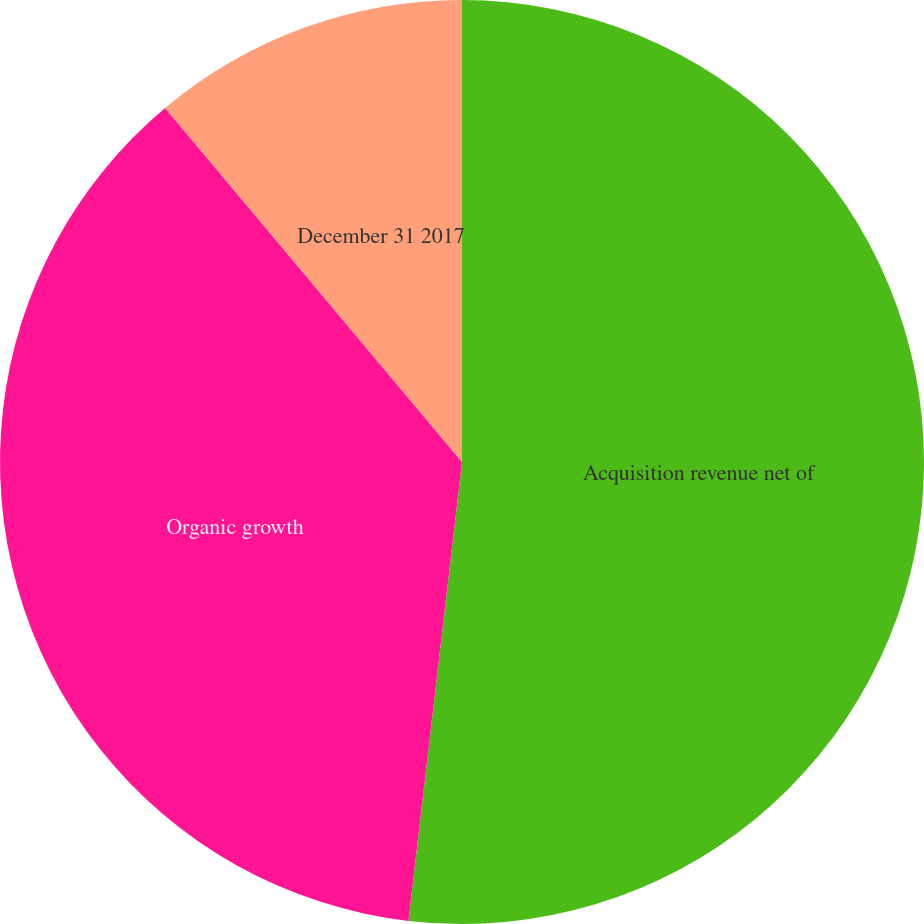Convert chart. <chart><loc_0><loc_0><loc_500><loc_500><pie_chart><fcel>Acquisition revenue net of<fcel>Organic growth<fcel>December 31 2017<nl><fcel>51.85%<fcel>37.04%<fcel>11.11%<nl></chart> 